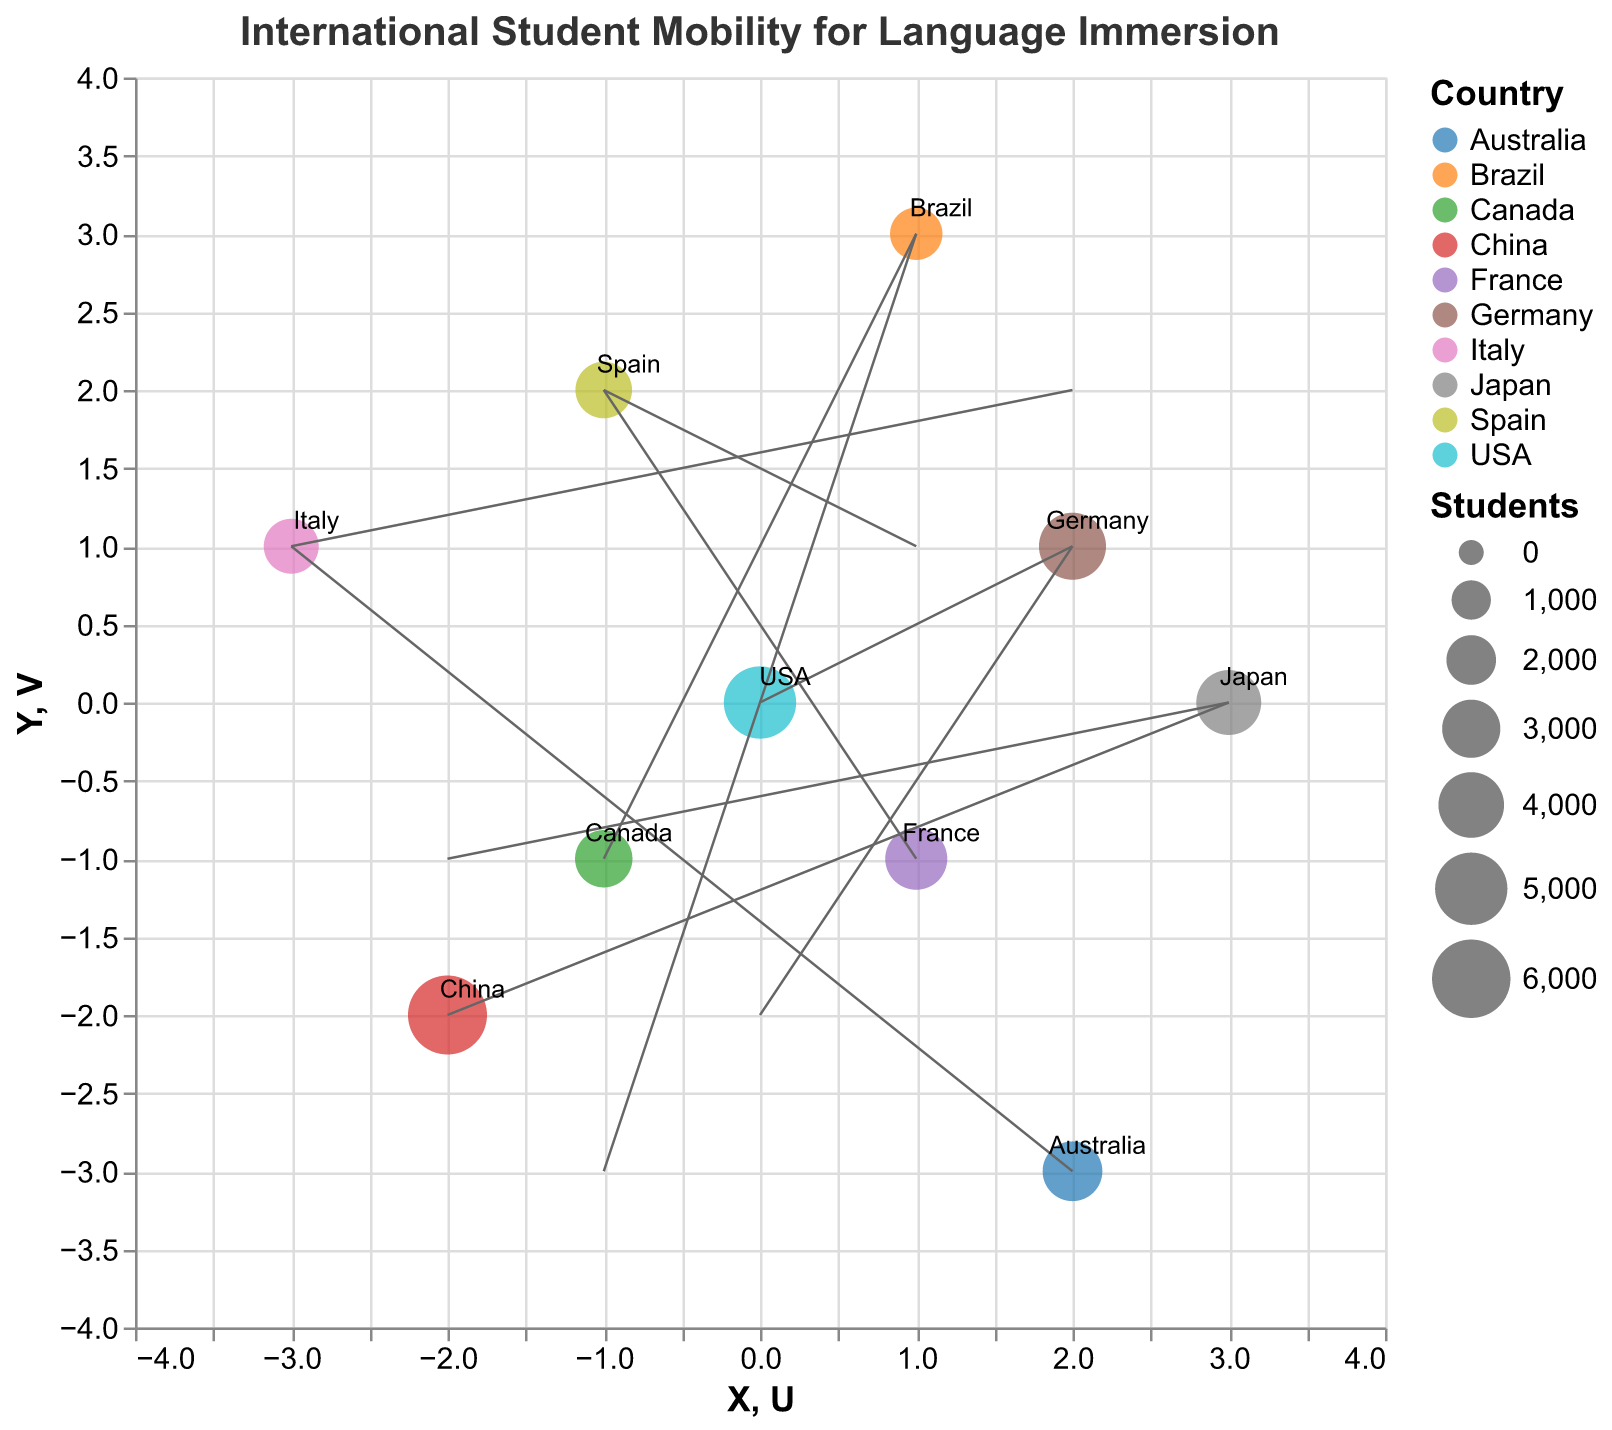What is the title of the quiver plot? The title of the plot is usually located at the top and describes the overall theme or subject of the chart.
Answer: International Student Mobility for Language Immersion How many data points are represented in the plot? Each data point corresponds to a country in the dataset; count the total number of countries.
Answer: 10 Which country has the highest number of students in language immersion programs? Look for the country that has the largest size point on the plot, which indicates the highest "Students" value.
Answer: China What direction is the quiver for Canada pointing? The quiver for Canada starts at (-1, -1) and ends at (1, 3). This means it points to the coordinates (1, 3) from (-1, -1), thus indicating a northeast direction.
Answer: Northeast Which country has a quiver vector length closest to zero? Calculate the length of each quiver vector using the formula √(U² + V²) and find the smallest one. The calculation shows that the vector length for Germany (0, -2) is √(0² + (-2)²) = 2.
Answer: Germany What is the relationship between the number of students from USA and France? Compare the Students value for USA (5000) and France (3500).
Answer: USA has more students than France How many countries have a positive U component in their vectors? Count the countries where the U value is greater than 0.
Answer: 5 Which country has its quiver vector ending closest to the origin? Calculate the ending coordinates of each quiver and find the one nearest to (0, 0). After finding all ending points, Italy's quiver ends at (-1, 3) which is closest to (0,0).
Answer: Italy What are the starting coordinates of the country with the fewest students? Identify the country with the smallest Students value which is Brazil (2300), then look for its starting coordinates (X, Y).
Answer: (1, 3) What is the average number of students across all countries? Sum the Students values and divide by the number of countries (10). The sum is 36500, so average is 36500 / 10.
Answer: 3650 